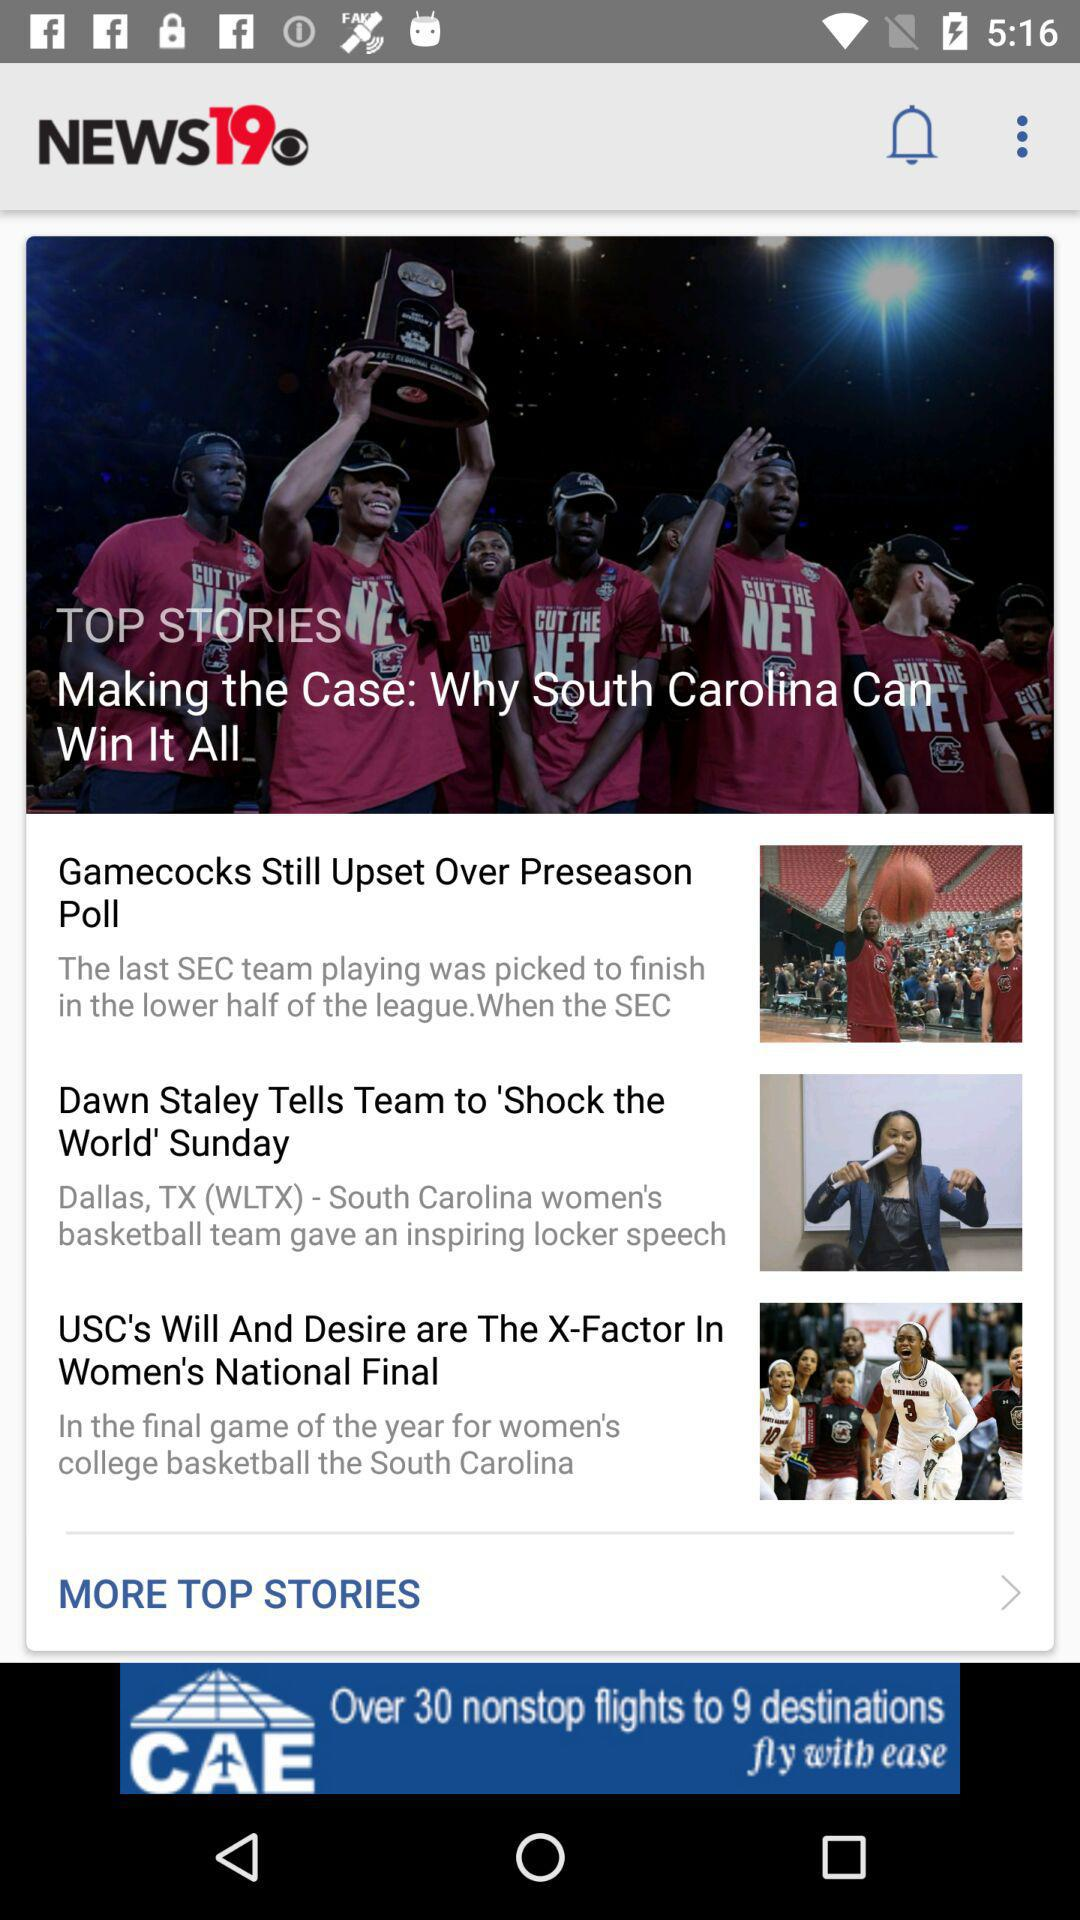What is the application name? The application name is "NEWS19". 